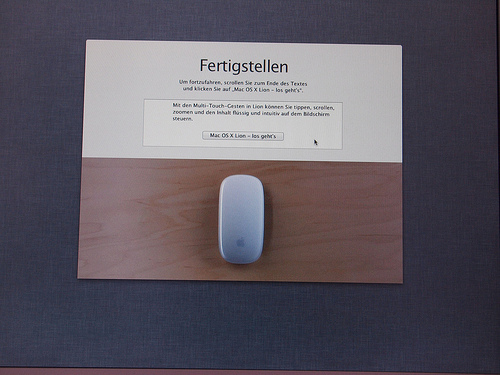<image>
Is there a wood under the paper? Yes. The wood is positioned underneath the paper, with the paper above it in the vertical space. 